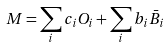<formula> <loc_0><loc_0><loc_500><loc_500>M = \sum _ { i } c _ { i } O _ { i } + \sum _ { i } b _ { i } \bar { B } _ { i }</formula> 